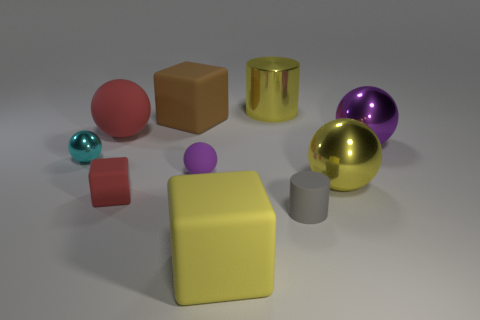There is a large yellow thing that is the same shape as the big brown object; what is it made of?
Provide a short and direct response. Rubber. There is a rubber cube in front of the matte object to the right of the big yellow metal cylinder; how big is it?
Offer a very short reply. Large. Is there a purple rubber thing?
Your answer should be very brief. Yes. What material is the thing that is behind the big purple metallic ball and in front of the big brown matte thing?
Offer a very short reply. Rubber. Is the number of tiny purple rubber objects to the right of the big red object greater than the number of purple metal things in front of the small purple matte object?
Keep it short and to the point. Yes. Are there any purple matte things of the same size as the gray object?
Your response must be concise. Yes. How big is the red thing that is in front of the tiny shiny object that is left of the purple thing on the right side of the tiny cylinder?
Offer a very short reply. Small. What color is the tiny cylinder?
Provide a succinct answer. Gray. Are there more big rubber objects behind the small gray cylinder than tiny gray cylinders?
Offer a very short reply. Yes. There is a yellow cube; what number of metallic balls are on the right side of it?
Provide a short and direct response. 2. 